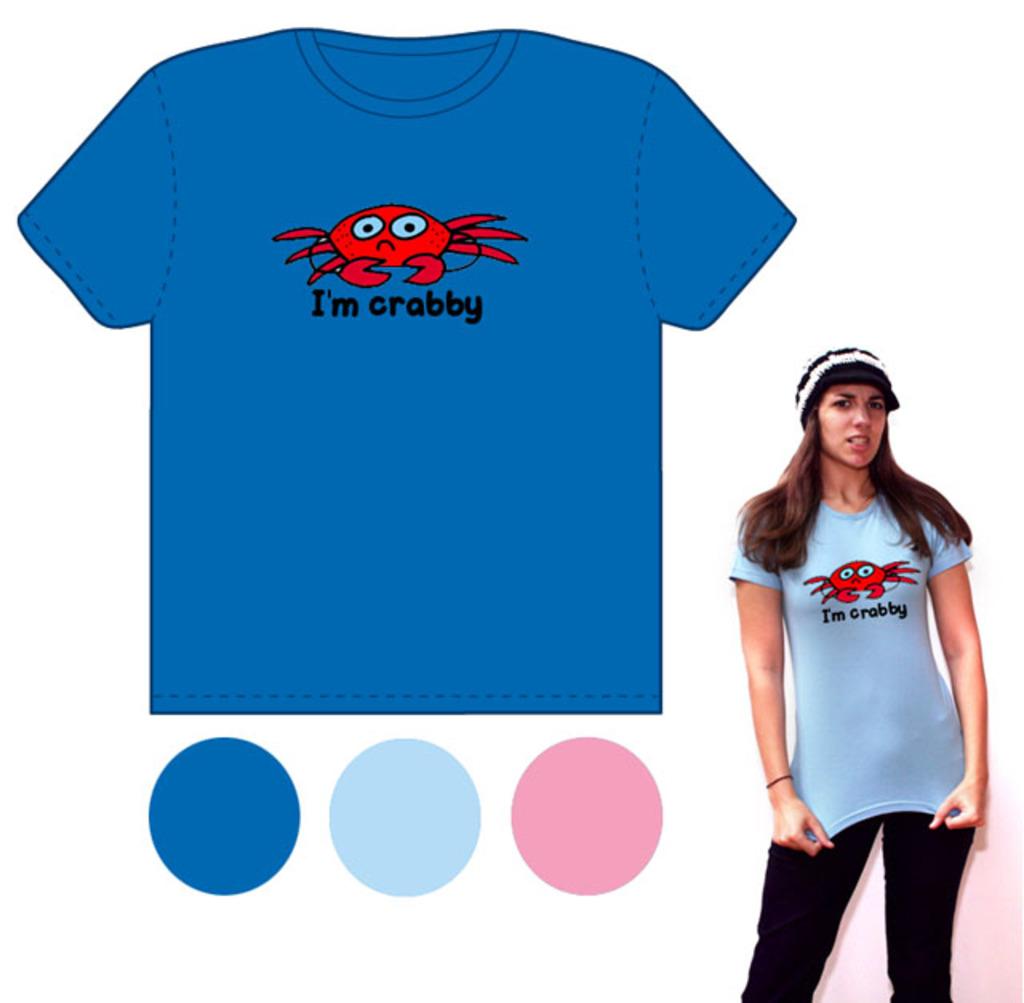What kind of animal is on the shirt?
Your answer should be compact. Crab. Who is crabby?
Make the answer very short. I'm. 